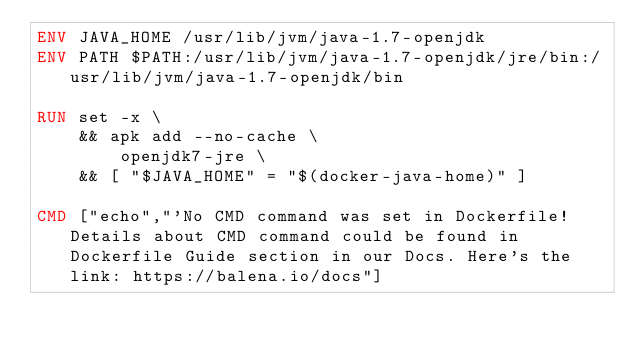<code> <loc_0><loc_0><loc_500><loc_500><_Dockerfile_>ENV JAVA_HOME /usr/lib/jvm/java-1.7-openjdk
ENV PATH $PATH:/usr/lib/jvm/java-1.7-openjdk/jre/bin:/usr/lib/jvm/java-1.7-openjdk/bin

RUN set -x \
	&& apk add --no-cache \
		openjdk7-jre \
	&& [ "$JAVA_HOME" = "$(docker-java-home)" ]

CMD ["echo","'No CMD command was set in Dockerfile! Details about CMD command could be found in Dockerfile Guide section in our Docs. Here's the link: https://balena.io/docs"]</code> 